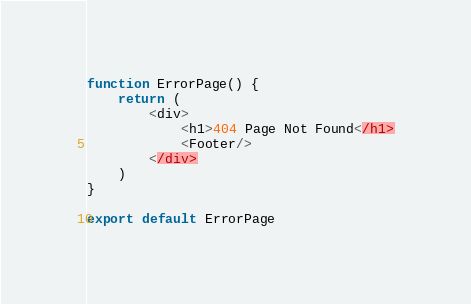Convert code to text. <code><loc_0><loc_0><loc_500><loc_500><_JavaScript_>function ErrorPage() {
    return (
        <div>
            <h1>404 Page Not Found</h1>
            <Footer/>
        </div>
    )
}

export default ErrorPage
</code> 